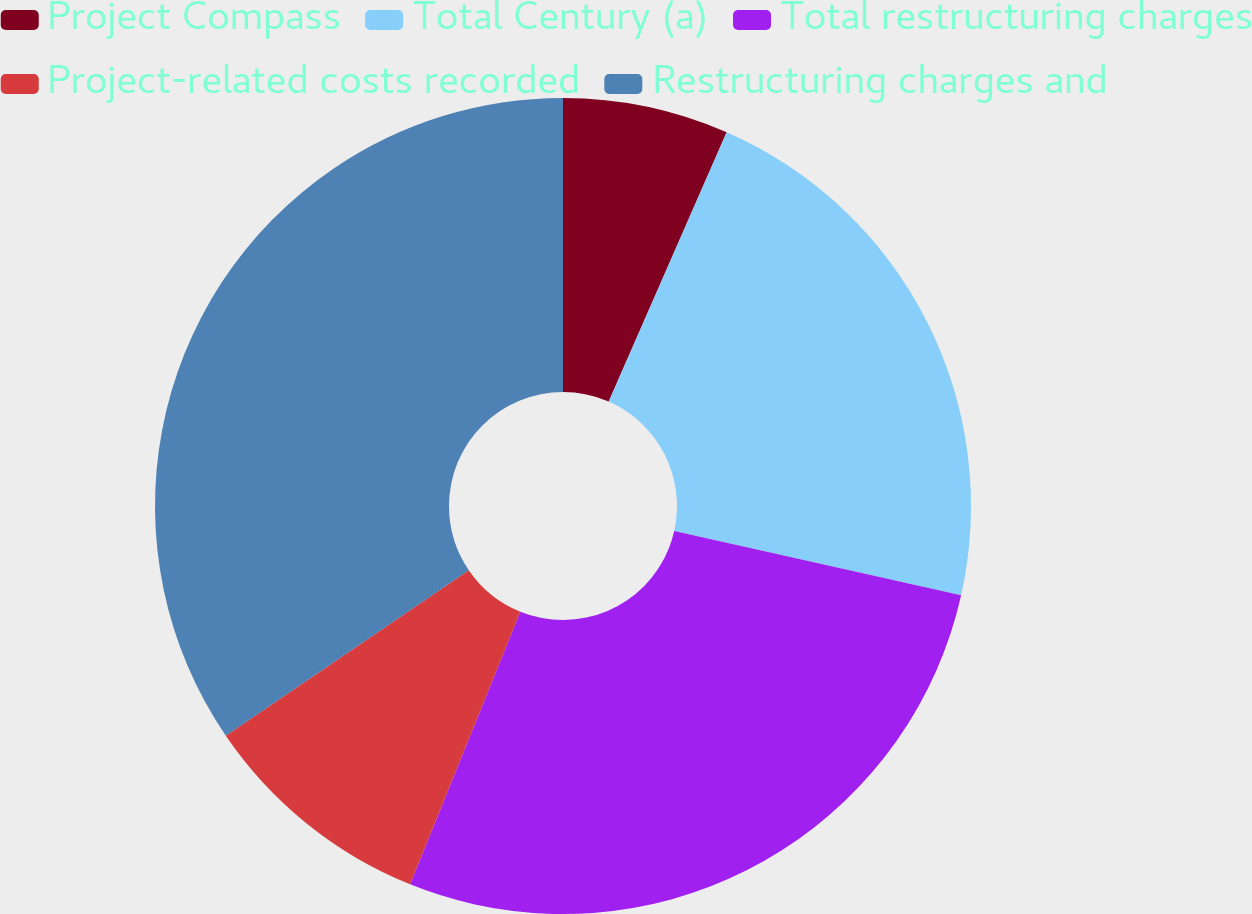<chart> <loc_0><loc_0><loc_500><loc_500><pie_chart><fcel>Project Compass<fcel>Total Century (a)<fcel>Total restructuring charges<fcel>Project-related costs recorded<fcel>Restructuring charges and<nl><fcel>6.57%<fcel>21.94%<fcel>27.61%<fcel>9.37%<fcel>34.52%<nl></chart> 